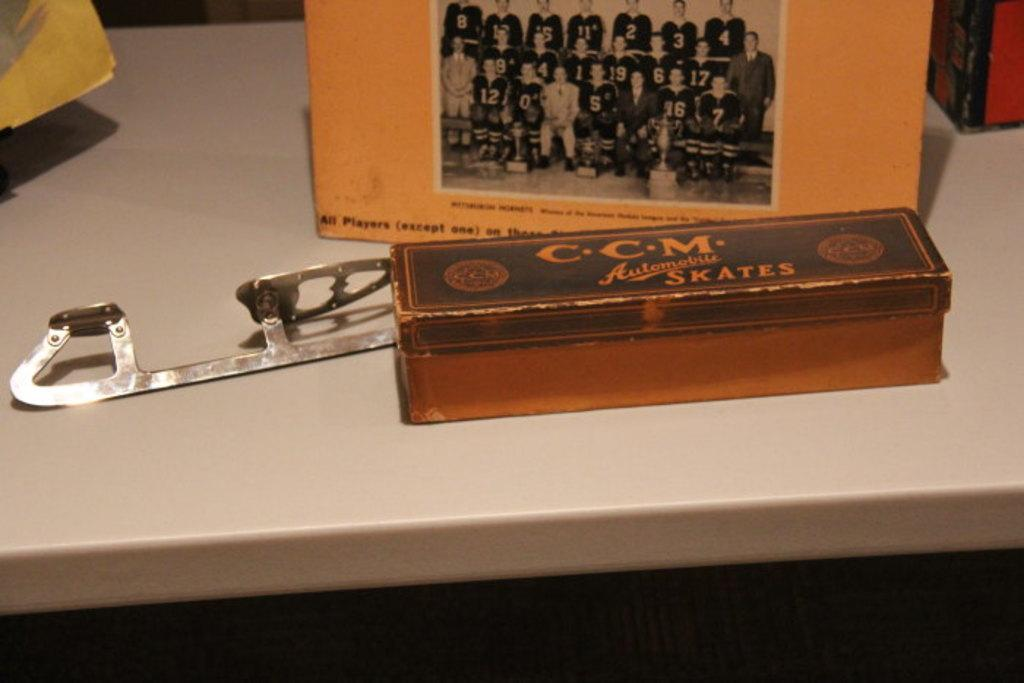Provide a one-sentence caption for the provided image. A metal box serves as the packaging for CCM Automatic Skates. 